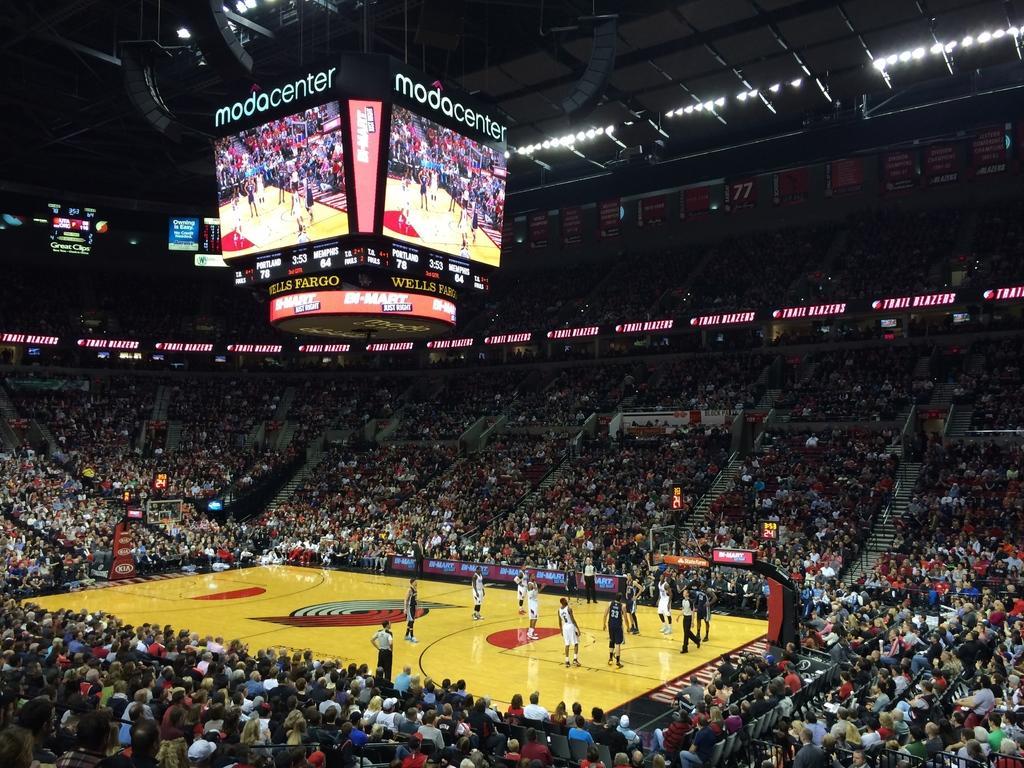Describe this image in one or two sentences. This image looks like a basketball stadium. There are many people in this image. In the middle, there is a basketball court and there are few people playing the game. To the top, there are screens. 